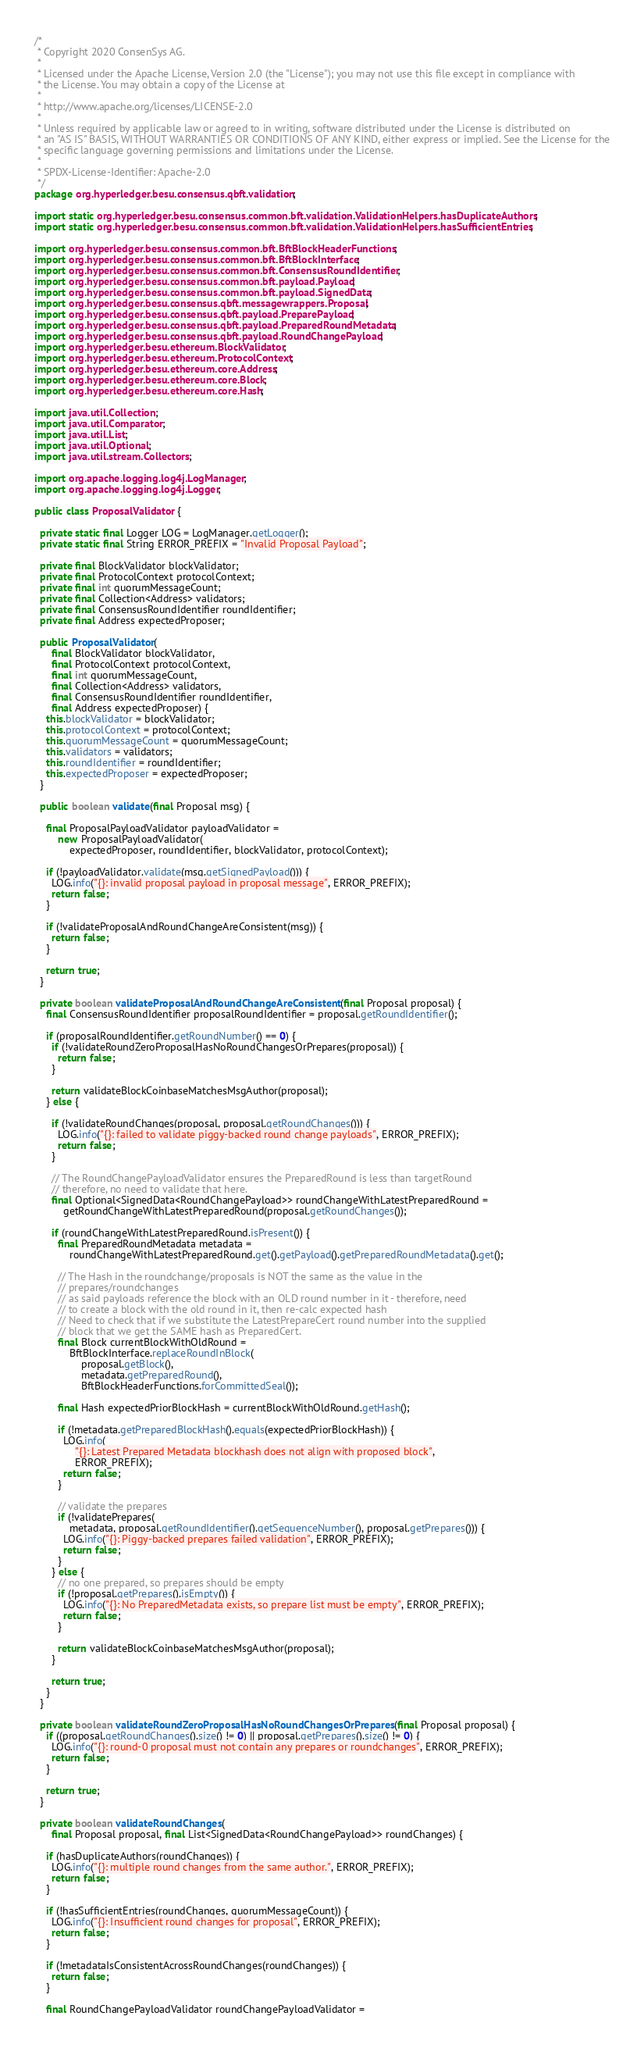Convert code to text. <code><loc_0><loc_0><loc_500><loc_500><_Java_>/*
 * Copyright 2020 ConsenSys AG.
 *
 * Licensed under the Apache License, Version 2.0 (the "License"); you may not use this file except in compliance with
 * the License. You may obtain a copy of the License at
 *
 * http://www.apache.org/licenses/LICENSE-2.0
 *
 * Unless required by applicable law or agreed to in writing, software distributed under the License is distributed on
 * an "AS IS" BASIS, WITHOUT WARRANTIES OR CONDITIONS OF ANY KIND, either express or implied. See the License for the
 * specific language governing permissions and limitations under the License.
 *
 * SPDX-License-Identifier: Apache-2.0
 */
package org.hyperledger.besu.consensus.qbft.validation;

import static org.hyperledger.besu.consensus.common.bft.validation.ValidationHelpers.hasDuplicateAuthors;
import static org.hyperledger.besu.consensus.common.bft.validation.ValidationHelpers.hasSufficientEntries;

import org.hyperledger.besu.consensus.common.bft.BftBlockHeaderFunctions;
import org.hyperledger.besu.consensus.common.bft.BftBlockInterface;
import org.hyperledger.besu.consensus.common.bft.ConsensusRoundIdentifier;
import org.hyperledger.besu.consensus.common.bft.payload.Payload;
import org.hyperledger.besu.consensus.common.bft.payload.SignedData;
import org.hyperledger.besu.consensus.qbft.messagewrappers.Proposal;
import org.hyperledger.besu.consensus.qbft.payload.PreparePayload;
import org.hyperledger.besu.consensus.qbft.payload.PreparedRoundMetadata;
import org.hyperledger.besu.consensus.qbft.payload.RoundChangePayload;
import org.hyperledger.besu.ethereum.BlockValidator;
import org.hyperledger.besu.ethereum.ProtocolContext;
import org.hyperledger.besu.ethereum.core.Address;
import org.hyperledger.besu.ethereum.core.Block;
import org.hyperledger.besu.ethereum.core.Hash;

import java.util.Collection;
import java.util.Comparator;
import java.util.List;
import java.util.Optional;
import java.util.stream.Collectors;

import org.apache.logging.log4j.LogManager;
import org.apache.logging.log4j.Logger;

public class ProposalValidator {

  private static final Logger LOG = LogManager.getLogger();
  private static final String ERROR_PREFIX = "Invalid Proposal Payload";

  private final BlockValidator blockValidator;
  private final ProtocolContext protocolContext;
  private final int quorumMessageCount;
  private final Collection<Address> validators;
  private final ConsensusRoundIdentifier roundIdentifier;
  private final Address expectedProposer;

  public ProposalValidator(
      final BlockValidator blockValidator,
      final ProtocolContext protocolContext,
      final int quorumMessageCount,
      final Collection<Address> validators,
      final ConsensusRoundIdentifier roundIdentifier,
      final Address expectedProposer) {
    this.blockValidator = blockValidator;
    this.protocolContext = protocolContext;
    this.quorumMessageCount = quorumMessageCount;
    this.validators = validators;
    this.roundIdentifier = roundIdentifier;
    this.expectedProposer = expectedProposer;
  }

  public boolean validate(final Proposal msg) {

    final ProposalPayloadValidator payloadValidator =
        new ProposalPayloadValidator(
            expectedProposer, roundIdentifier, blockValidator, protocolContext);

    if (!payloadValidator.validate(msg.getSignedPayload())) {
      LOG.info("{}: invalid proposal payload in proposal message", ERROR_PREFIX);
      return false;
    }

    if (!validateProposalAndRoundChangeAreConsistent(msg)) {
      return false;
    }

    return true;
  }

  private boolean validateProposalAndRoundChangeAreConsistent(final Proposal proposal) {
    final ConsensusRoundIdentifier proposalRoundIdentifier = proposal.getRoundIdentifier();

    if (proposalRoundIdentifier.getRoundNumber() == 0) {
      if (!validateRoundZeroProposalHasNoRoundChangesOrPrepares(proposal)) {
        return false;
      }

      return validateBlockCoinbaseMatchesMsgAuthor(proposal);
    } else {

      if (!validateRoundChanges(proposal, proposal.getRoundChanges())) {
        LOG.info("{}: failed to validate piggy-backed round change payloads", ERROR_PREFIX);
        return false;
      }

      // The RoundChangePayloadValidator ensures the PreparedRound is less than targetRound
      // therefore, no need to validate that here.
      final Optional<SignedData<RoundChangePayload>> roundChangeWithLatestPreparedRound =
          getRoundChangeWithLatestPreparedRound(proposal.getRoundChanges());

      if (roundChangeWithLatestPreparedRound.isPresent()) {
        final PreparedRoundMetadata metadata =
            roundChangeWithLatestPreparedRound.get().getPayload().getPreparedRoundMetadata().get();

        // The Hash in the roundchange/proposals is NOT the same as the value in the
        // prepares/roundchanges
        // as said payloads reference the block with an OLD round number in it - therefore, need
        // to create a block with the old round in it, then re-calc expected hash
        // Need to check that if we substitute the LatestPrepareCert round number into the supplied
        // block that we get the SAME hash as PreparedCert.
        final Block currentBlockWithOldRound =
            BftBlockInterface.replaceRoundInBlock(
                proposal.getBlock(),
                metadata.getPreparedRound(),
                BftBlockHeaderFunctions.forCommittedSeal());

        final Hash expectedPriorBlockHash = currentBlockWithOldRound.getHash();

        if (!metadata.getPreparedBlockHash().equals(expectedPriorBlockHash)) {
          LOG.info(
              "{}: Latest Prepared Metadata blockhash does not align with proposed block",
              ERROR_PREFIX);
          return false;
        }

        // validate the prepares
        if (!validatePrepares(
            metadata, proposal.getRoundIdentifier().getSequenceNumber(), proposal.getPrepares())) {
          LOG.info("{}: Piggy-backed prepares failed validation", ERROR_PREFIX);
          return false;
        }
      } else {
        // no one prepared, so prepares should be empty
        if (!proposal.getPrepares().isEmpty()) {
          LOG.info("{}: No PreparedMetadata exists, so prepare list must be empty", ERROR_PREFIX);
          return false;
        }

        return validateBlockCoinbaseMatchesMsgAuthor(proposal);
      }

      return true;
    }
  }

  private boolean validateRoundZeroProposalHasNoRoundChangesOrPrepares(final Proposal proposal) {
    if ((proposal.getRoundChanges().size() != 0) || proposal.getPrepares().size() != 0) {
      LOG.info("{}: round-0 proposal must not contain any prepares or roundchanges", ERROR_PREFIX);
      return false;
    }

    return true;
  }

  private boolean validateRoundChanges(
      final Proposal proposal, final List<SignedData<RoundChangePayload>> roundChanges) {

    if (hasDuplicateAuthors(roundChanges)) {
      LOG.info("{}: multiple round changes from the same author.", ERROR_PREFIX);
      return false;
    }

    if (!hasSufficientEntries(roundChanges, quorumMessageCount)) {
      LOG.info("{}: Insufficient round changes for proposal", ERROR_PREFIX);
      return false;
    }

    if (!metadataIsConsistentAcrossRoundChanges(roundChanges)) {
      return false;
    }

    final RoundChangePayloadValidator roundChangePayloadValidator =</code> 